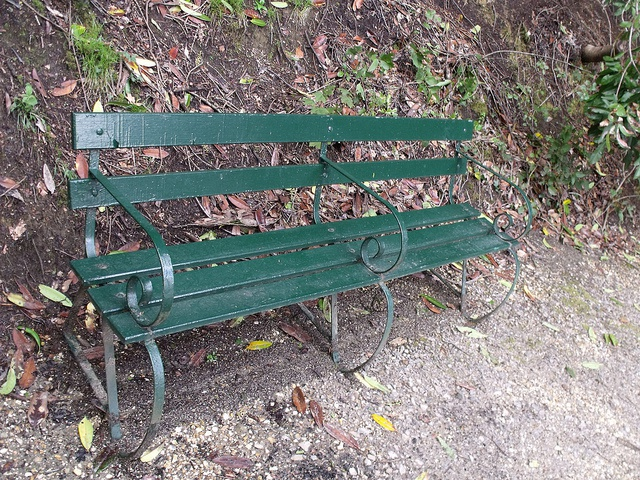Describe the objects in this image and their specific colors. I can see a bench in black, teal, gray, and darkgray tones in this image. 